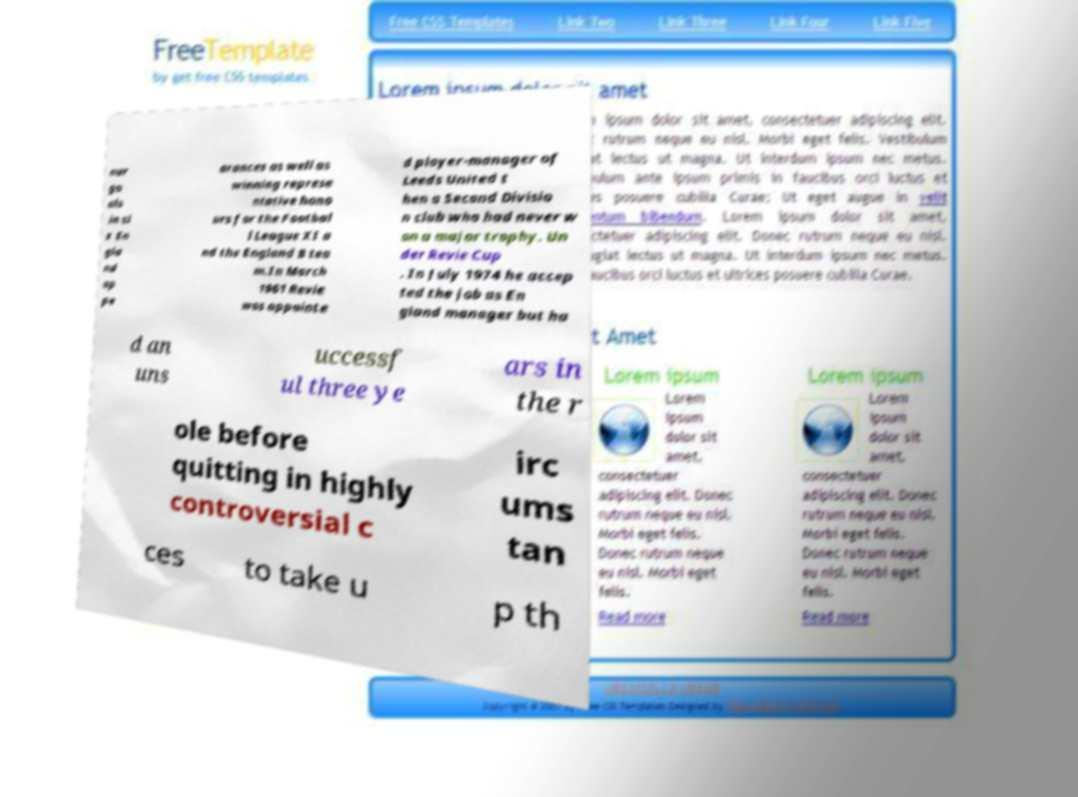Could you assist in decoding the text presented in this image and type it out clearly? our go als in si x En gla nd ap pe arances as well as winning represe ntative hono urs for the Footbal l League XI a nd the England B tea m.In March 1961 Revie was appointe d player-manager of Leeds United t hen a Second Divisio n club who had never w on a major trophy. Un der Revie Cup . In July 1974 he accep ted the job as En gland manager but ha d an uns uccessf ul three ye ars in the r ole before quitting in highly controversial c irc ums tan ces to take u p th 